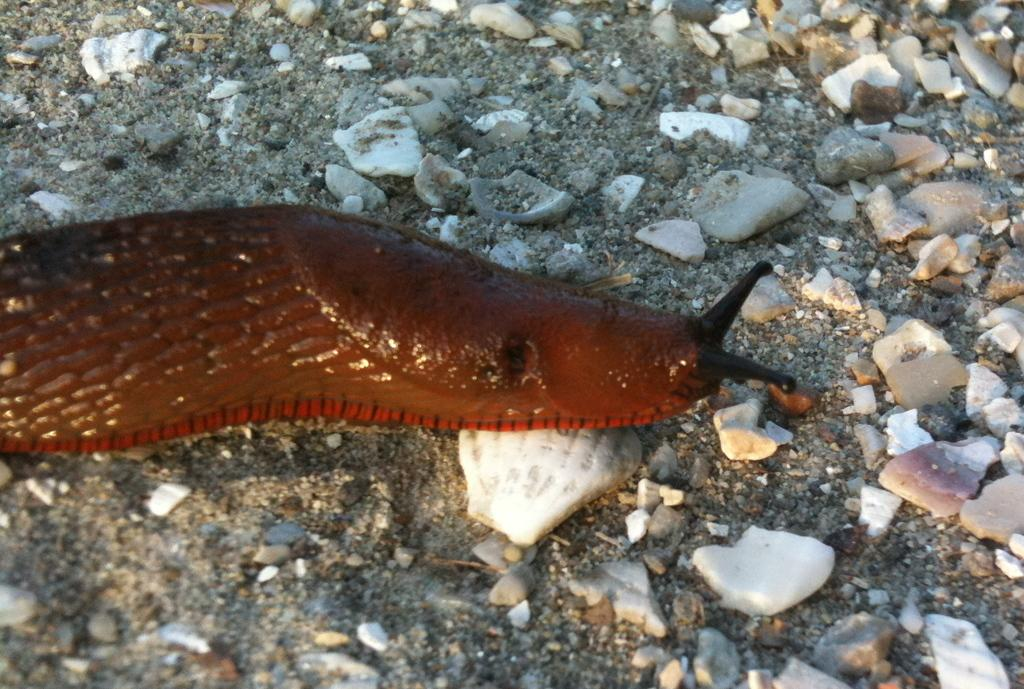What type of animal is in the center of the image? There is a water animal in the center of the image. What can be seen in the background of the image? Ground and stones are visible in the background of the image. What type of street is visible in the image? There is no street visible in the image; it features a water animal and a background with ground and stones. 